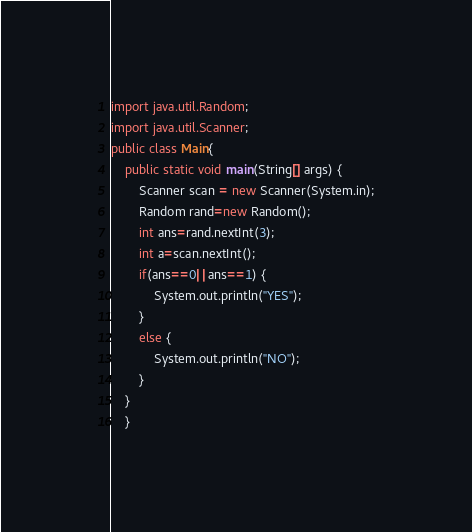<code> <loc_0><loc_0><loc_500><loc_500><_Java_>import java.util.Random;
import java.util.Scanner;
public class Main{
	public static void main(String[] args) {
		Scanner scan = new Scanner(System.in);
		Random rand=new Random();
		int ans=rand.nextInt(3);
		int a=scan.nextInt();
		if(ans==0||ans==1) {
			System.out.println("YES");
		}
		else {
			System.out.println("NO");
		}
	}
	}</code> 